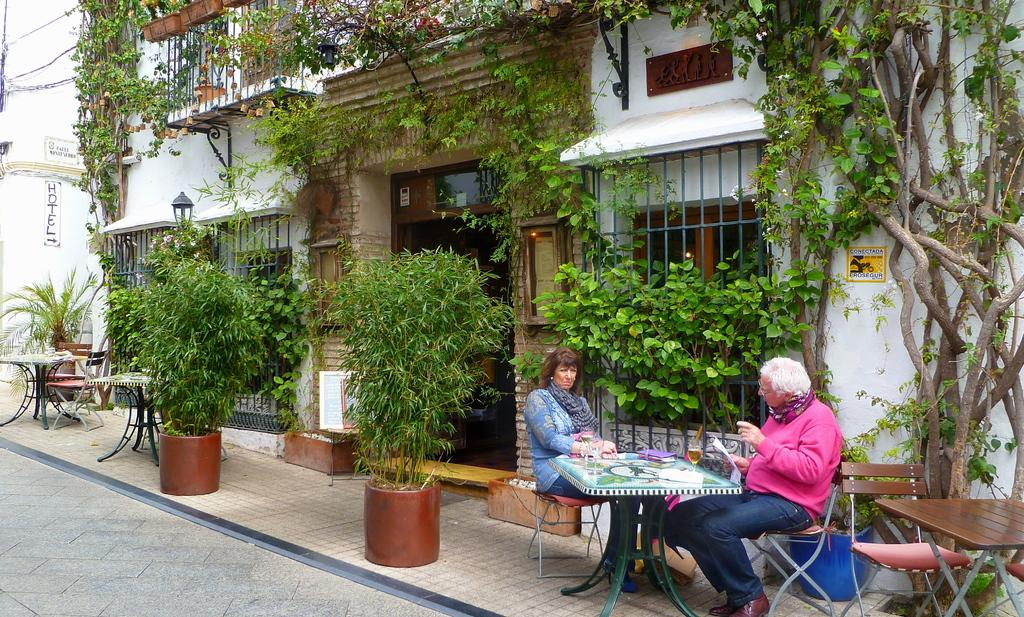What type of structure is visible in the picture? There is a house in the picture. What else can be seen in the picture besides the house? There are plants and two people seated on chairs in the picture. What is the purpose of the chairs in the picture? The chairs are likely for the people to sit on. What is the table used for in the picture? The table might be used for holding objects or serving food. Can you tell me the minute hand's position on the clock in the picture? There is no clock visible in the picture, so it is not possible to determine the position of the minute hand. 